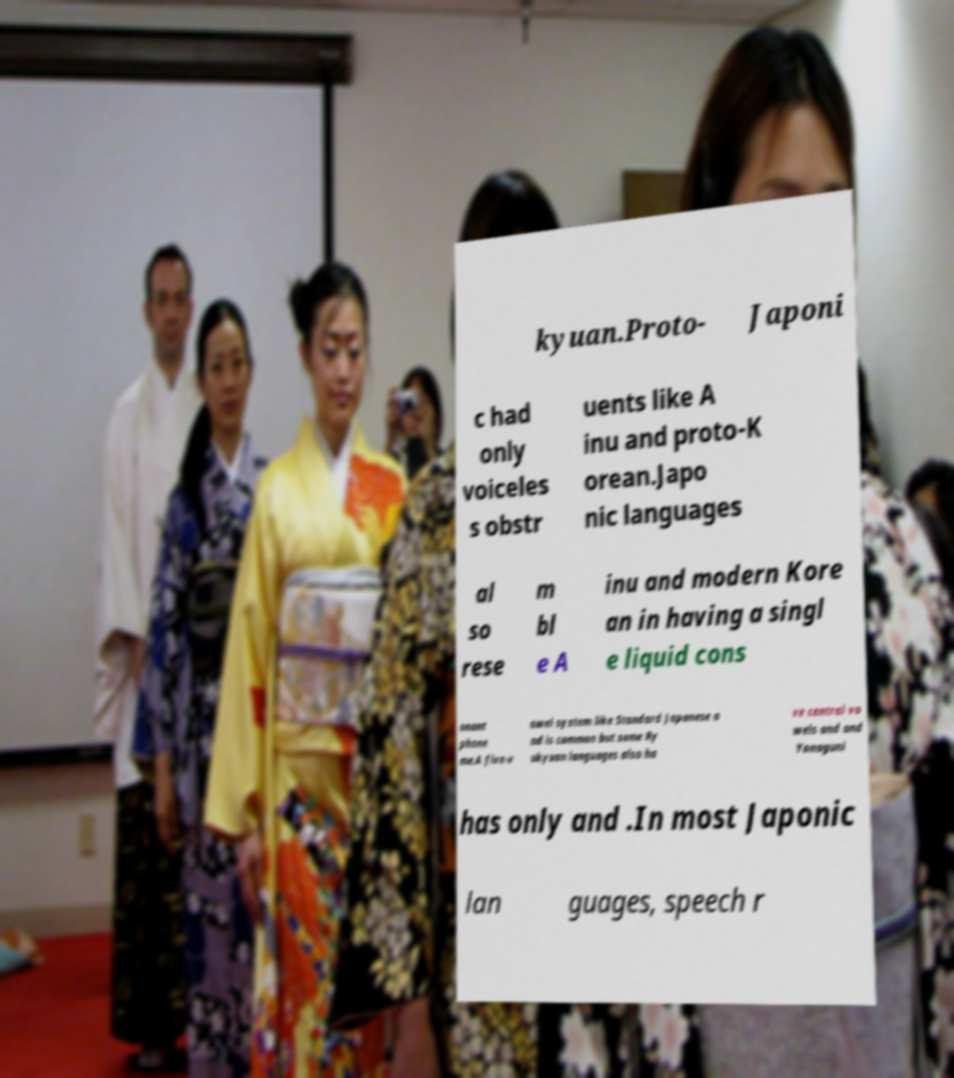There's text embedded in this image that I need extracted. Can you transcribe it verbatim? kyuan.Proto- Japoni c had only voiceles s obstr uents like A inu and proto-K orean.Japo nic languages al so rese m bl e A inu and modern Kore an in having a singl e liquid cons onant phone me.A five-v owel system like Standard Japanese a nd is common but some Ry ukyuan languages also ha ve central vo wels and and Yonaguni has only and .In most Japonic lan guages, speech r 